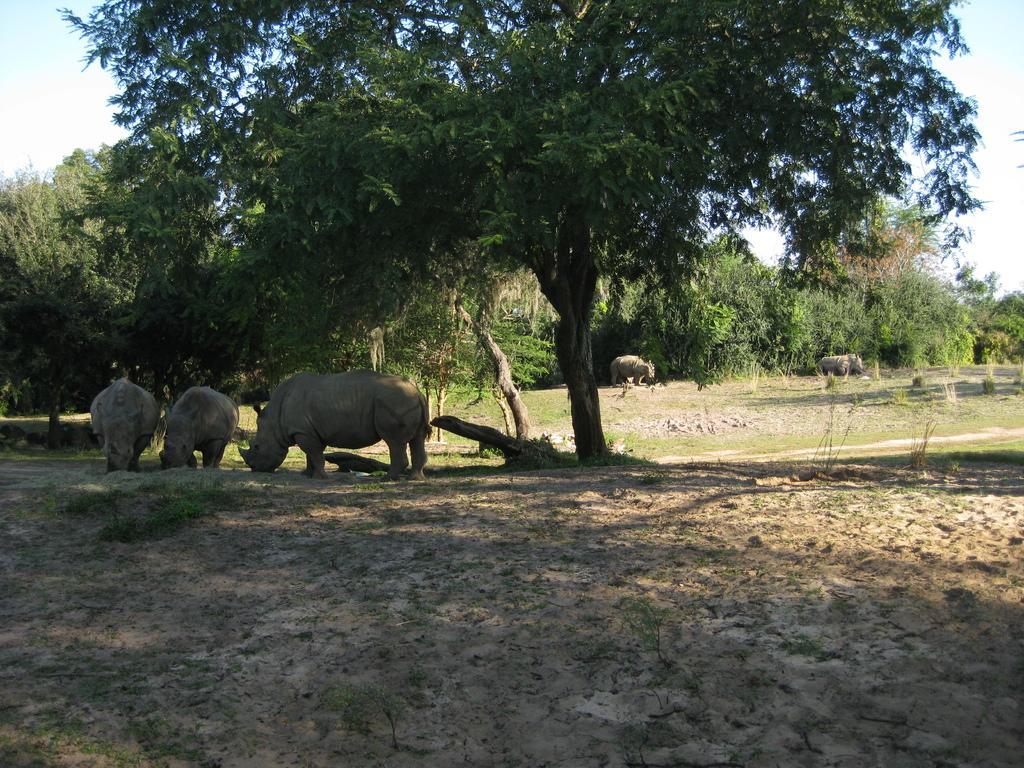Describe this image in one or two sentences. In this picture we can see animals on the ground and in the background we can see trees and the sky. 